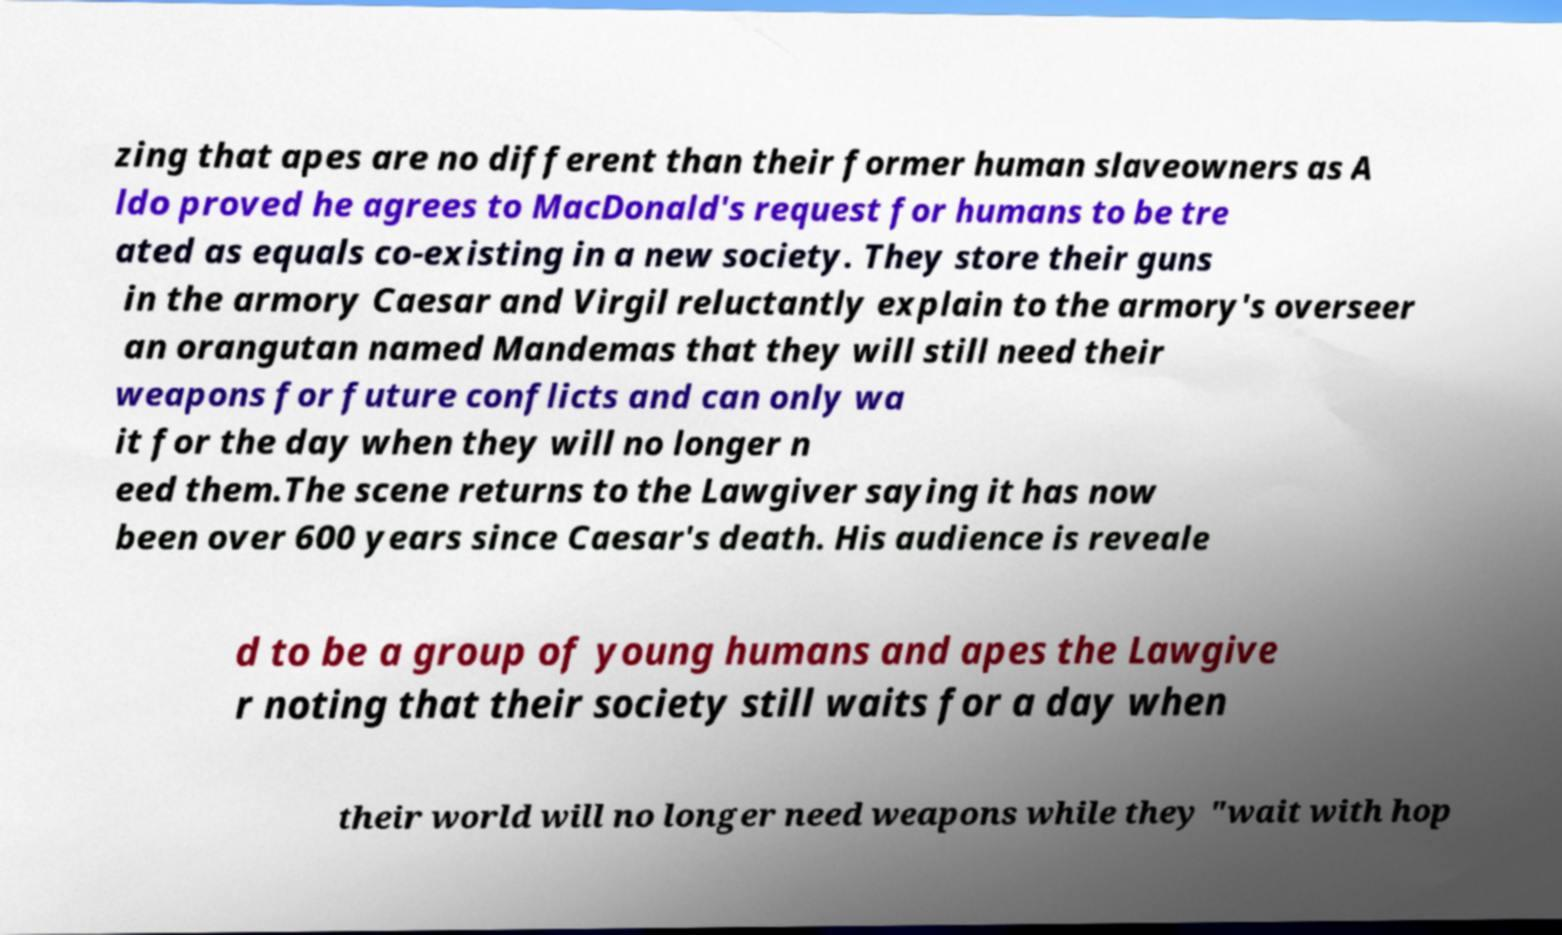Please identify and transcribe the text found in this image. zing that apes are no different than their former human slaveowners as A ldo proved he agrees to MacDonald's request for humans to be tre ated as equals co-existing in a new society. They store their guns in the armory Caesar and Virgil reluctantly explain to the armory's overseer an orangutan named Mandemas that they will still need their weapons for future conflicts and can only wa it for the day when they will no longer n eed them.The scene returns to the Lawgiver saying it has now been over 600 years since Caesar's death. His audience is reveale d to be a group of young humans and apes the Lawgive r noting that their society still waits for a day when their world will no longer need weapons while they "wait with hop 